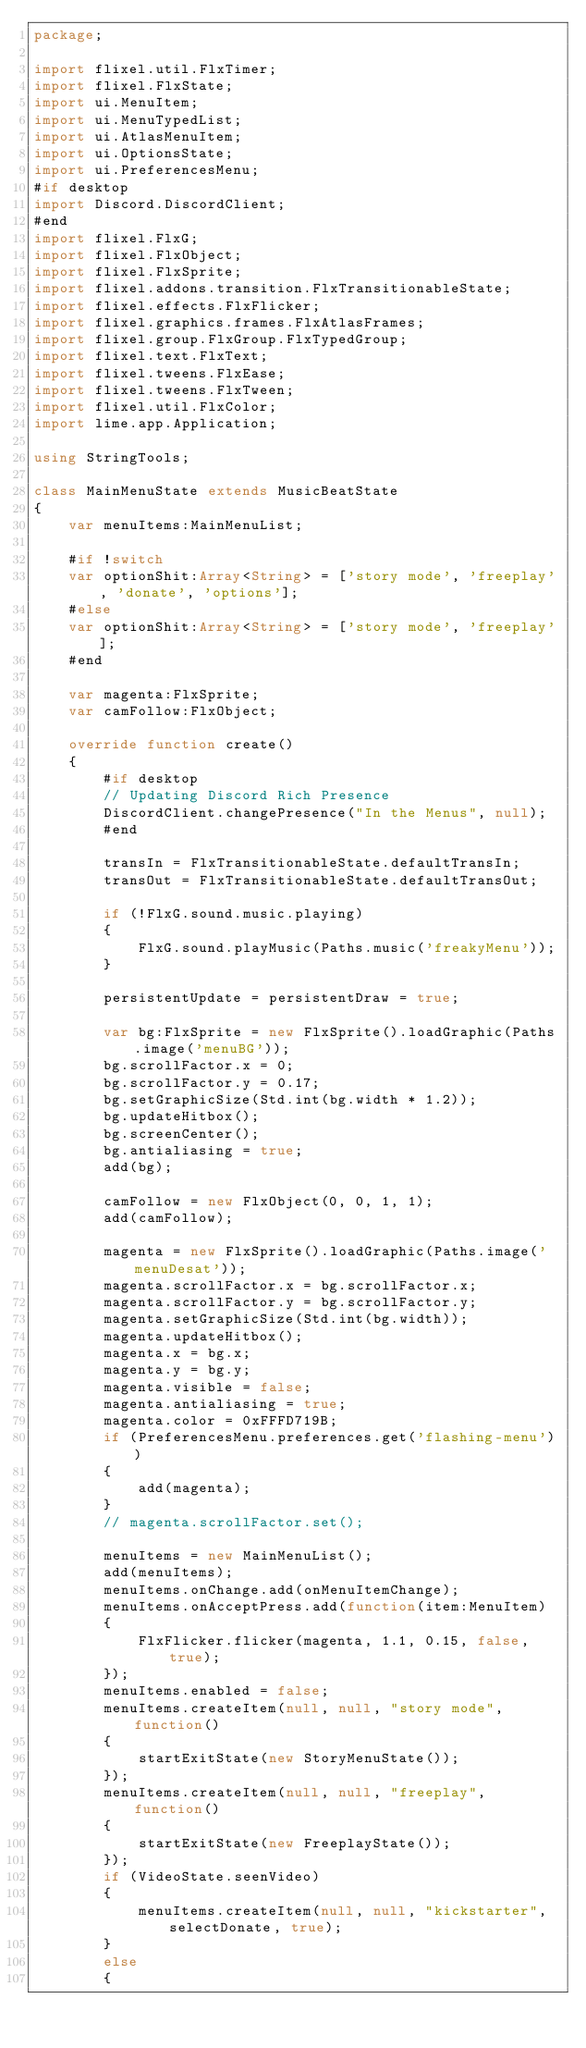Convert code to text. <code><loc_0><loc_0><loc_500><loc_500><_Haxe_>package;

import flixel.util.FlxTimer;
import flixel.FlxState;
import ui.MenuItem;
import ui.MenuTypedList;
import ui.AtlasMenuItem;
import ui.OptionsState;
import ui.PreferencesMenu;
#if desktop
import Discord.DiscordClient;
#end
import flixel.FlxG;
import flixel.FlxObject;
import flixel.FlxSprite;
import flixel.addons.transition.FlxTransitionableState;
import flixel.effects.FlxFlicker;
import flixel.graphics.frames.FlxAtlasFrames;
import flixel.group.FlxGroup.FlxTypedGroup;
import flixel.text.FlxText;
import flixel.tweens.FlxEase;
import flixel.tweens.FlxTween;
import flixel.util.FlxColor;
import lime.app.Application;

using StringTools;

class MainMenuState extends MusicBeatState
{
	var menuItems:MainMenuList;

	#if !switch
	var optionShit:Array<String> = ['story mode', 'freeplay', 'donate', 'options'];
	#else
	var optionShit:Array<String> = ['story mode', 'freeplay'];
	#end

	var magenta:FlxSprite;
	var camFollow:FlxObject;

	override function create()
	{
		#if desktop
		// Updating Discord Rich Presence
		DiscordClient.changePresence("In the Menus", null);
		#end

		transIn = FlxTransitionableState.defaultTransIn;
		transOut = FlxTransitionableState.defaultTransOut;

		if (!FlxG.sound.music.playing)
		{
			FlxG.sound.playMusic(Paths.music('freakyMenu'));
		}

		persistentUpdate = persistentDraw = true;

		var bg:FlxSprite = new FlxSprite().loadGraphic(Paths.image('menuBG'));
		bg.scrollFactor.x = 0;
		bg.scrollFactor.y = 0.17;
		bg.setGraphicSize(Std.int(bg.width * 1.2));
		bg.updateHitbox();
		bg.screenCenter();
		bg.antialiasing = true;
		add(bg);

		camFollow = new FlxObject(0, 0, 1, 1);
		add(camFollow);

		magenta = new FlxSprite().loadGraphic(Paths.image('menuDesat'));
		magenta.scrollFactor.x = bg.scrollFactor.x;
		magenta.scrollFactor.y = bg.scrollFactor.y;
		magenta.setGraphicSize(Std.int(bg.width));
		magenta.updateHitbox();
		magenta.x = bg.x;
		magenta.y = bg.y;
		magenta.visible = false;
		magenta.antialiasing = true;
		magenta.color = 0xFFFD719B;
		if (PreferencesMenu.preferences.get('flashing-menu'))
		{
			add(magenta);
		}
		// magenta.scrollFactor.set();

		menuItems = new MainMenuList();
		add(menuItems);
		menuItems.onChange.add(onMenuItemChange);
		menuItems.onAcceptPress.add(function(item:MenuItem)
		{
			FlxFlicker.flicker(magenta, 1.1, 0.15, false, true);
		});
		menuItems.enabled = false;
		menuItems.createItem(null, null, "story mode", function()
		{
			startExitState(new StoryMenuState());
		});
		menuItems.createItem(null, null, "freeplay", function()
		{
			startExitState(new FreeplayState());
		});
		if (VideoState.seenVideo)
		{
			menuItems.createItem(null, null, "kickstarter", selectDonate, true);
		}
		else
		{</code> 